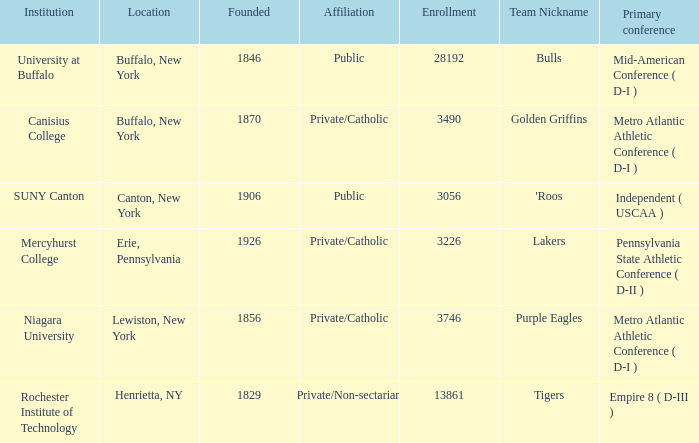In 1846, how many students were registered at the school that was founded? 28192.0. 